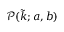Convert formula to latex. <formula><loc_0><loc_0><loc_500><loc_500>\mathcal { P } ( \tilde { k } ; a , b )</formula> 